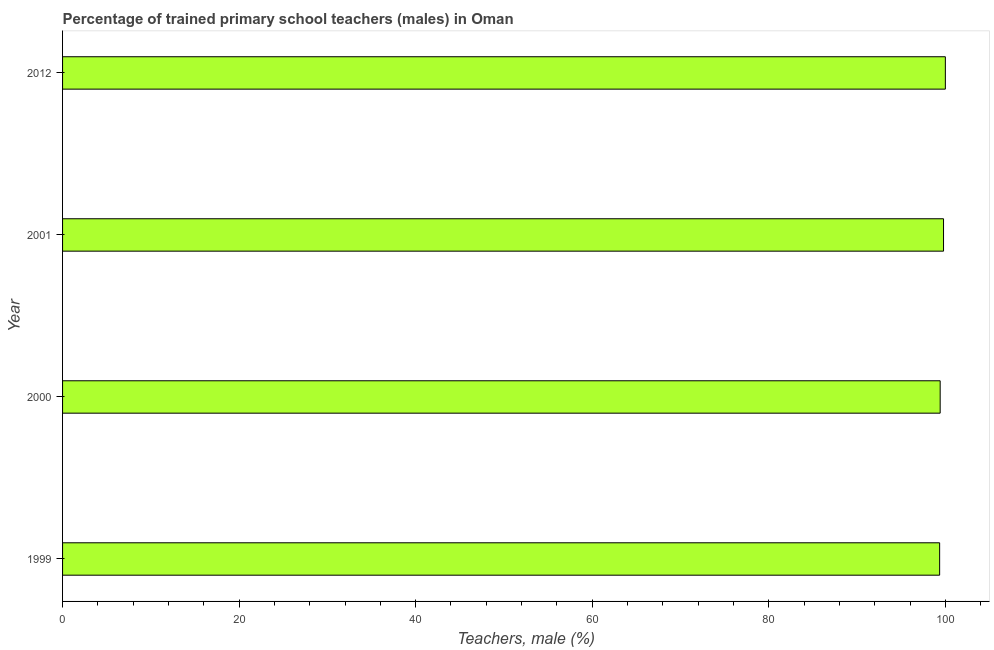Does the graph contain grids?
Keep it short and to the point. No. What is the title of the graph?
Provide a short and direct response. Percentage of trained primary school teachers (males) in Oman. What is the label or title of the X-axis?
Keep it short and to the point. Teachers, male (%). What is the label or title of the Y-axis?
Your answer should be compact. Year. What is the percentage of trained male teachers in 1999?
Provide a short and direct response. 99.35. Across all years, what is the maximum percentage of trained male teachers?
Offer a terse response. 100. Across all years, what is the minimum percentage of trained male teachers?
Your answer should be very brief. 99.35. In which year was the percentage of trained male teachers minimum?
Your answer should be compact. 1999. What is the sum of the percentage of trained male teachers?
Ensure brevity in your answer.  398.56. What is the difference between the percentage of trained male teachers in 1999 and 2001?
Your answer should be very brief. -0.44. What is the average percentage of trained male teachers per year?
Provide a succinct answer. 99.64. What is the median percentage of trained male teachers?
Your answer should be very brief. 99.6. In how many years, is the percentage of trained male teachers greater than 28 %?
Provide a succinct answer. 4. Do a majority of the years between 1999 and 2000 (inclusive) have percentage of trained male teachers greater than 36 %?
Your response must be concise. Yes. What is the difference between the highest and the second highest percentage of trained male teachers?
Give a very brief answer. 0.21. What is the difference between the highest and the lowest percentage of trained male teachers?
Keep it short and to the point. 0.65. In how many years, is the percentage of trained male teachers greater than the average percentage of trained male teachers taken over all years?
Make the answer very short. 2. Are all the bars in the graph horizontal?
Your answer should be very brief. Yes. What is the difference between two consecutive major ticks on the X-axis?
Offer a very short reply. 20. Are the values on the major ticks of X-axis written in scientific E-notation?
Provide a succinct answer. No. What is the Teachers, male (%) of 1999?
Make the answer very short. 99.35. What is the Teachers, male (%) in 2000?
Offer a terse response. 99.41. What is the Teachers, male (%) in 2001?
Provide a succinct answer. 99.79. What is the difference between the Teachers, male (%) in 1999 and 2000?
Your answer should be very brief. -0.06. What is the difference between the Teachers, male (%) in 1999 and 2001?
Make the answer very short. -0.44. What is the difference between the Teachers, male (%) in 1999 and 2012?
Your answer should be compact. -0.65. What is the difference between the Teachers, male (%) in 2000 and 2001?
Ensure brevity in your answer.  -0.38. What is the difference between the Teachers, male (%) in 2000 and 2012?
Ensure brevity in your answer.  -0.59. What is the difference between the Teachers, male (%) in 2001 and 2012?
Your response must be concise. -0.21. What is the ratio of the Teachers, male (%) in 1999 to that in 2001?
Your answer should be very brief. 1. What is the ratio of the Teachers, male (%) in 2001 to that in 2012?
Give a very brief answer. 1. 